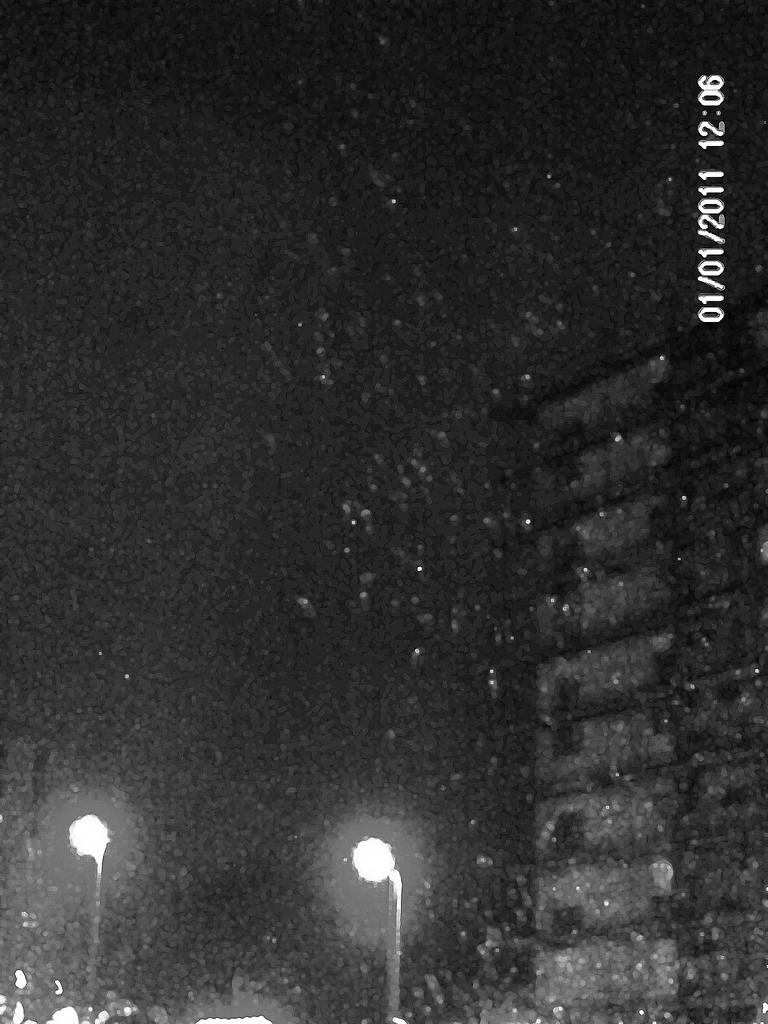What is the main subject of the image? The main subject of the image is a building. Can you describe the building in the image? The building has multiple floors and windows. Are there any other elements visible in the image? Yes, there are poles with street lights near the building. What type of ear can be seen on the building in the image? There is no ear present on the building in the image; it is a structure, not a living being. 